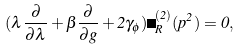<formula> <loc_0><loc_0><loc_500><loc_500>( \lambda \frac { \partial } { \partial \lambda } + \beta \frac { \partial } { \partial g } + 2 \gamma _ { \phi } ) \Gamma _ { R } ^ { ( 2 ) } ( p ^ { 2 } ) = 0 ,</formula> 